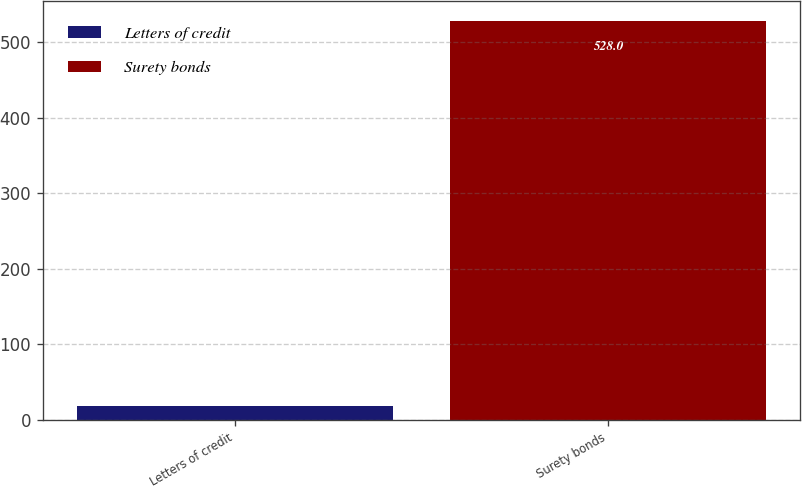<chart> <loc_0><loc_0><loc_500><loc_500><bar_chart><fcel>Letters of credit<fcel>Surety bonds<nl><fcel>18<fcel>528<nl></chart> 